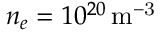Convert formula to latex. <formula><loc_0><loc_0><loc_500><loc_500>n _ { e } = 1 0 ^ { 2 0 } { \, m ^ { - 3 } }</formula> 